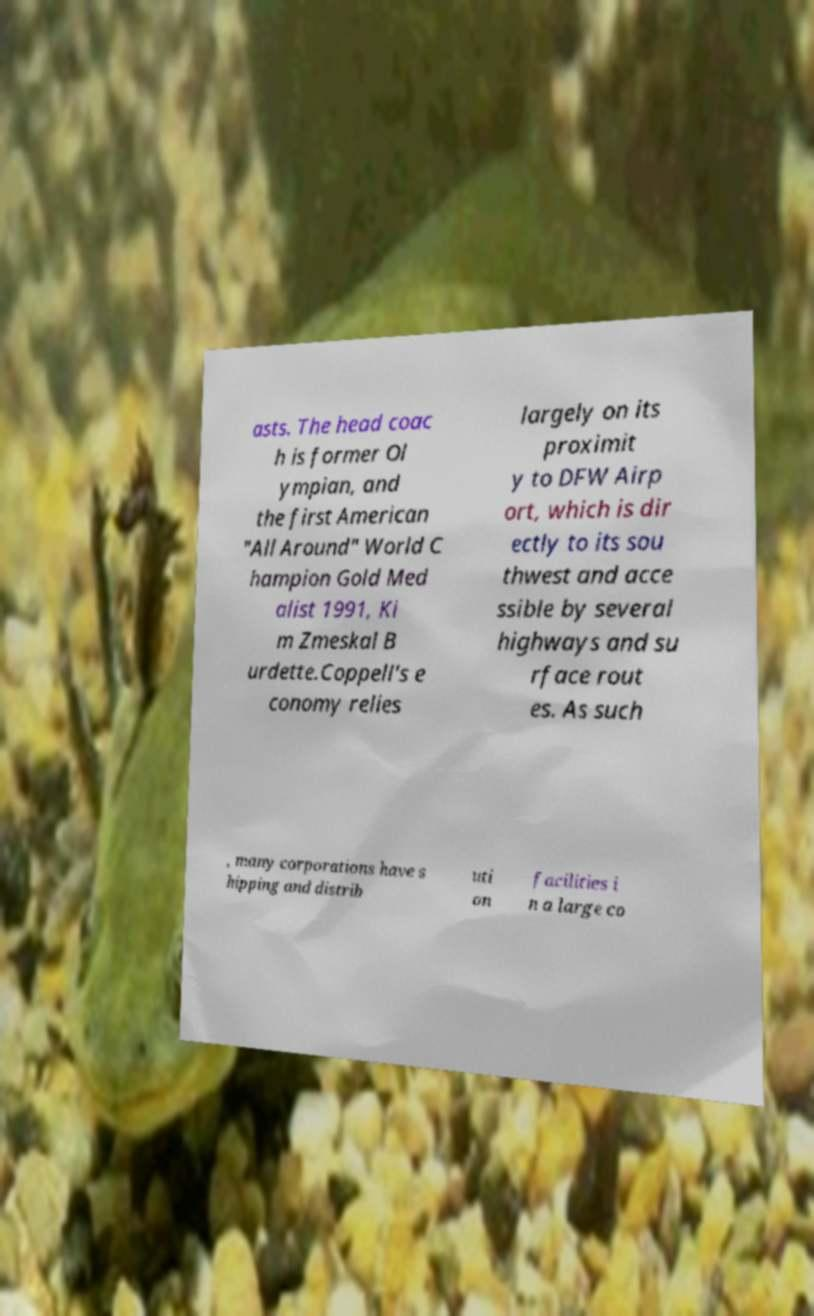There's text embedded in this image that I need extracted. Can you transcribe it verbatim? asts. The head coac h is former Ol ympian, and the first American "All Around" World C hampion Gold Med alist 1991, Ki m Zmeskal B urdette.Coppell's e conomy relies largely on its proximit y to DFW Airp ort, which is dir ectly to its sou thwest and acce ssible by several highways and su rface rout es. As such , many corporations have s hipping and distrib uti on facilities i n a large co 